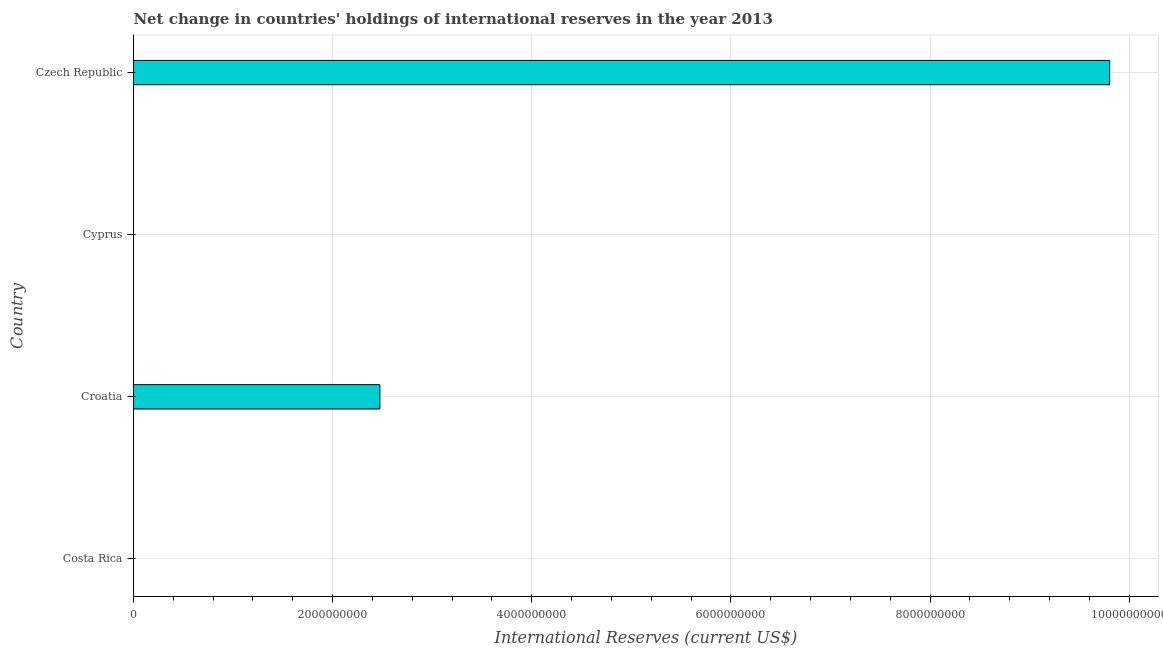What is the title of the graph?
Your answer should be very brief. Net change in countries' holdings of international reserves in the year 2013. What is the label or title of the X-axis?
Offer a very short reply. International Reserves (current US$). What is the reserves and related items in Czech Republic?
Ensure brevity in your answer.  9.80e+09. Across all countries, what is the maximum reserves and related items?
Keep it short and to the point. 9.80e+09. In which country was the reserves and related items maximum?
Keep it short and to the point. Czech Republic. What is the sum of the reserves and related items?
Give a very brief answer. 1.23e+1. What is the difference between the reserves and related items in Croatia and Czech Republic?
Keep it short and to the point. -7.33e+09. What is the average reserves and related items per country?
Provide a succinct answer. 3.07e+09. What is the median reserves and related items?
Provide a short and direct response. 1.24e+09. What is the ratio of the reserves and related items in Croatia to that in Czech Republic?
Offer a terse response. 0.25. Is the reserves and related items in Croatia less than that in Czech Republic?
Keep it short and to the point. Yes. Is the difference between the reserves and related items in Croatia and Czech Republic greater than the difference between any two countries?
Provide a succinct answer. No. What is the difference between the highest and the lowest reserves and related items?
Keep it short and to the point. 9.80e+09. Are all the bars in the graph horizontal?
Your response must be concise. Yes. What is the difference between two consecutive major ticks on the X-axis?
Provide a succinct answer. 2.00e+09. What is the International Reserves (current US$) of Croatia?
Provide a succinct answer. 2.47e+09. What is the International Reserves (current US$) in Cyprus?
Your answer should be very brief. 0. What is the International Reserves (current US$) of Czech Republic?
Provide a short and direct response. 9.80e+09. What is the difference between the International Reserves (current US$) in Croatia and Czech Republic?
Your response must be concise. -7.33e+09. What is the ratio of the International Reserves (current US$) in Croatia to that in Czech Republic?
Provide a succinct answer. 0.25. 